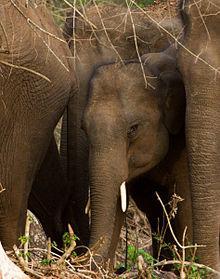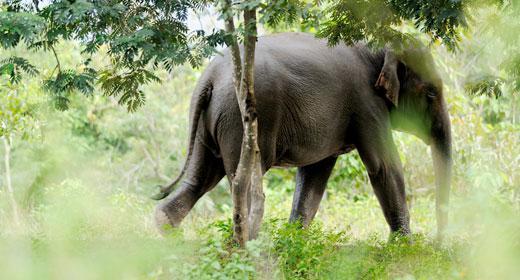The first image is the image on the left, the second image is the image on the right. Considering the images on both sides, is "In one image, an elephant is in or near water." valid? Answer yes or no. No. The first image is the image on the left, the second image is the image on the right. Examine the images to the left and right. Is the description "A body of water is visible in one of the images." accurate? Answer yes or no. No. 